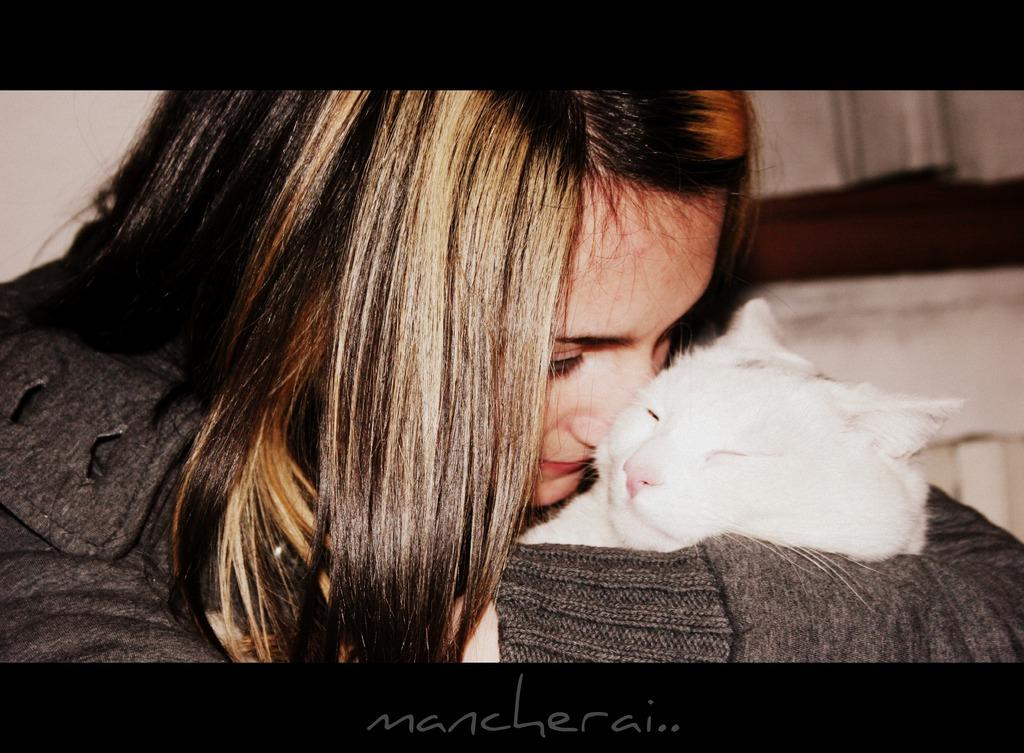Who is present in the image? There is a woman in the image. What is the woman holding in the image? The woman is holding a white cat. How is the image presented? The image appears to be framed. What additional information is provided below the image? There is text below the image. What can be seen in the background of the image? There is a wall in the background of the image. What time of day is the moon visible in the image? The moon is not visible in the image; it is a picture of a woman holding a white cat with a wall in the background. 